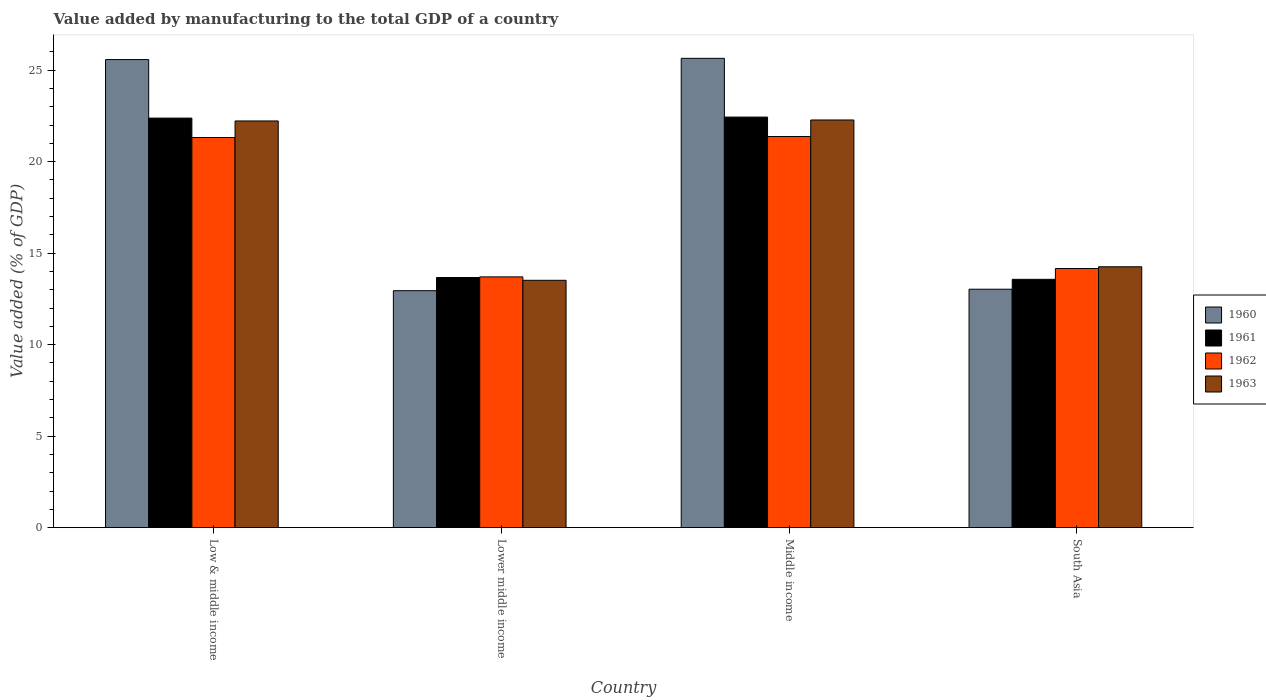How many different coloured bars are there?
Your answer should be very brief. 4. Are the number of bars per tick equal to the number of legend labels?
Give a very brief answer. Yes. Are the number of bars on each tick of the X-axis equal?
Offer a terse response. Yes. How many bars are there on the 4th tick from the left?
Keep it short and to the point. 4. How many bars are there on the 1st tick from the right?
Offer a terse response. 4. In how many cases, is the number of bars for a given country not equal to the number of legend labels?
Your answer should be very brief. 0. What is the value added by manufacturing to the total GDP in 1963 in South Asia?
Your answer should be compact. 14.26. Across all countries, what is the maximum value added by manufacturing to the total GDP in 1960?
Provide a short and direct response. 25.65. Across all countries, what is the minimum value added by manufacturing to the total GDP in 1962?
Ensure brevity in your answer.  13.7. In which country was the value added by manufacturing to the total GDP in 1963 maximum?
Give a very brief answer. Middle income. In which country was the value added by manufacturing to the total GDP in 1963 minimum?
Your answer should be very brief. Lower middle income. What is the total value added by manufacturing to the total GDP in 1963 in the graph?
Give a very brief answer. 72.27. What is the difference between the value added by manufacturing to the total GDP in 1961 in Low & middle income and that in Middle income?
Keep it short and to the point. -0.06. What is the difference between the value added by manufacturing to the total GDP in 1961 in South Asia and the value added by manufacturing to the total GDP in 1963 in Lower middle income?
Your answer should be very brief. 0.05. What is the average value added by manufacturing to the total GDP in 1963 per country?
Keep it short and to the point. 18.07. What is the difference between the value added by manufacturing to the total GDP of/in 1963 and value added by manufacturing to the total GDP of/in 1960 in South Asia?
Ensure brevity in your answer.  1.23. What is the ratio of the value added by manufacturing to the total GDP in 1963 in Low & middle income to that in Lower middle income?
Keep it short and to the point. 1.64. Is the value added by manufacturing to the total GDP in 1962 in Lower middle income less than that in South Asia?
Make the answer very short. Yes. Is the difference between the value added by manufacturing to the total GDP in 1963 in Low & middle income and Lower middle income greater than the difference between the value added by manufacturing to the total GDP in 1960 in Low & middle income and Lower middle income?
Give a very brief answer. No. What is the difference between the highest and the second highest value added by manufacturing to the total GDP in 1963?
Your response must be concise. -8.02. What is the difference between the highest and the lowest value added by manufacturing to the total GDP in 1960?
Your answer should be very brief. 12.7. In how many countries, is the value added by manufacturing to the total GDP in 1960 greater than the average value added by manufacturing to the total GDP in 1960 taken over all countries?
Provide a short and direct response. 2. Is the sum of the value added by manufacturing to the total GDP in 1960 in Middle income and South Asia greater than the maximum value added by manufacturing to the total GDP in 1961 across all countries?
Your response must be concise. Yes. Is it the case that in every country, the sum of the value added by manufacturing to the total GDP in 1960 and value added by manufacturing to the total GDP in 1963 is greater than the sum of value added by manufacturing to the total GDP in 1962 and value added by manufacturing to the total GDP in 1961?
Offer a terse response. No. What is the difference between two consecutive major ticks on the Y-axis?
Provide a short and direct response. 5. Are the values on the major ticks of Y-axis written in scientific E-notation?
Ensure brevity in your answer.  No. How are the legend labels stacked?
Give a very brief answer. Vertical. What is the title of the graph?
Your response must be concise. Value added by manufacturing to the total GDP of a country. What is the label or title of the X-axis?
Offer a very short reply. Country. What is the label or title of the Y-axis?
Keep it short and to the point. Value added (% of GDP). What is the Value added (% of GDP) in 1960 in Low & middle income?
Make the answer very short. 25.58. What is the Value added (% of GDP) of 1961 in Low & middle income?
Provide a succinct answer. 22.38. What is the Value added (% of GDP) of 1962 in Low & middle income?
Provide a short and direct response. 21.32. What is the Value added (% of GDP) of 1963 in Low & middle income?
Keep it short and to the point. 22.22. What is the Value added (% of GDP) in 1960 in Lower middle income?
Provide a short and direct response. 12.95. What is the Value added (% of GDP) of 1961 in Lower middle income?
Your answer should be compact. 13.67. What is the Value added (% of GDP) in 1962 in Lower middle income?
Your response must be concise. 13.7. What is the Value added (% of GDP) in 1963 in Lower middle income?
Your answer should be very brief. 13.52. What is the Value added (% of GDP) of 1960 in Middle income?
Make the answer very short. 25.65. What is the Value added (% of GDP) in 1961 in Middle income?
Your answer should be very brief. 22.44. What is the Value added (% of GDP) of 1962 in Middle income?
Provide a short and direct response. 21.37. What is the Value added (% of GDP) of 1963 in Middle income?
Make the answer very short. 22.28. What is the Value added (% of GDP) in 1960 in South Asia?
Ensure brevity in your answer.  13.03. What is the Value added (% of GDP) in 1961 in South Asia?
Make the answer very short. 13.57. What is the Value added (% of GDP) in 1962 in South Asia?
Give a very brief answer. 14.16. What is the Value added (% of GDP) in 1963 in South Asia?
Your answer should be compact. 14.26. Across all countries, what is the maximum Value added (% of GDP) in 1960?
Provide a short and direct response. 25.65. Across all countries, what is the maximum Value added (% of GDP) in 1961?
Offer a very short reply. 22.44. Across all countries, what is the maximum Value added (% of GDP) of 1962?
Your answer should be compact. 21.37. Across all countries, what is the maximum Value added (% of GDP) of 1963?
Provide a short and direct response. 22.28. Across all countries, what is the minimum Value added (% of GDP) in 1960?
Make the answer very short. 12.95. Across all countries, what is the minimum Value added (% of GDP) in 1961?
Your response must be concise. 13.57. Across all countries, what is the minimum Value added (% of GDP) in 1962?
Your answer should be very brief. 13.7. Across all countries, what is the minimum Value added (% of GDP) in 1963?
Your answer should be very brief. 13.52. What is the total Value added (% of GDP) in 1960 in the graph?
Make the answer very short. 77.2. What is the total Value added (% of GDP) in 1961 in the graph?
Your response must be concise. 72.05. What is the total Value added (% of GDP) in 1962 in the graph?
Offer a terse response. 70.56. What is the total Value added (% of GDP) of 1963 in the graph?
Your response must be concise. 72.27. What is the difference between the Value added (% of GDP) in 1960 in Low & middle income and that in Lower middle income?
Give a very brief answer. 12.63. What is the difference between the Value added (% of GDP) of 1961 in Low & middle income and that in Lower middle income?
Make the answer very short. 8.71. What is the difference between the Value added (% of GDP) of 1962 in Low & middle income and that in Lower middle income?
Offer a terse response. 7.62. What is the difference between the Value added (% of GDP) of 1963 in Low & middle income and that in Lower middle income?
Your answer should be very brief. 8.71. What is the difference between the Value added (% of GDP) in 1960 in Low & middle income and that in Middle income?
Give a very brief answer. -0.07. What is the difference between the Value added (% of GDP) in 1961 in Low & middle income and that in Middle income?
Provide a short and direct response. -0.06. What is the difference between the Value added (% of GDP) in 1962 in Low & middle income and that in Middle income?
Provide a short and direct response. -0.05. What is the difference between the Value added (% of GDP) in 1963 in Low & middle income and that in Middle income?
Offer a very short reply. -0.05. What is the difference between the Value added (% of GDP) of 1960 in Low & middle income and that in South Asia?
Your response must be concise. 12.55. What is the difference between the Value added (% of GDP) of 1961 in Low & middle income and that in South Asia?
Offer a terse response. 8.81. What is the difference between the Value added (% of GDP) of 1962 in Low & middle income and that in South Asia?
Keep it short and to the point. 7.16. What is the difference between the Value added (% of GDP) in 1963 in Low & middle income and that in South Asia?
Make the answer very short. 7.97. What is the difference between the Value added (% of GDP) in 1960 in Lower middle income and that in Middle income?
Provide a succinct answer. -12.7. What is the difference between the Value added (% of GDP) in 1961 in Lower middle income and that in Middle income?
Ensure brevity in your answer.  -8.77. What is the difference between the Value added (% of GDP) of 1962 in Lower middle income and that in Middle income?
Offer a terse response. -7.67. What is the difference between the Value added (% of GDP) of 1963 in Lower middle income and that in Middle income?
Your answer should be compact. -8.76. What is the difference between the Value added (% of GDP) in 1960 in Lower middle income and that in South Asia?
Ensure brevity in your answer.  -0.08. What is the difference between the Value added (% of GDP) of 1961 in Lower middle income and that in South Asia?
Ensure brevity in your answer.  0.1. What is the difference between the Value added (% of GDP) of 1962 in Lower middle income and that in South Asia?
Your response must be concise. -0.46. What is the difference between the Value added (% of GDP) of 1963 in Lower middle income and that in South Asia?
Provide a short and direct response. -0.74. What is the difference between the Value added (% of GDP) in 1960 in Middle income and that in South Asia?
Your answer should be very brief. 12.62. What is the difference between the Value added (% of GDP) of 1961 in Middle income and that in South Asia?
Give a very brief answer. 8.87. What is the difference between the Value added (% of GDP) of 1962 in Middle income and that in South Asia?
Your answer should be very brief. 7.21. What is the difference between the Value added (% of GDP) in 1963 in Middle income and that in South Asia?
Provide a succinct answer. 8.02. What is the difference between the Value added (% of GDP) of 1960 in Low & middle income and the Value added (% of GDP) of 1961 in Lower middle income?
Your answer should be very brief. 11.91. What is the difference between the Value added (% of GDP) in 1960 in Low & middle income and the Value added (% of GDP) in 1962 in Lower middle income?
Give a very brief answer. 11.88. What is the difference between the Value added (% of GDP) in 1960 in Low & middle income and the Value added (% of GDP) in 1963 in Lower middle income?
Your response must be concise. 12.06. What is the difference between the Value added (% of GDP) in 1961 in Low & middle income and the Value added (% of GDP) in 1962 in Lower middle income?
Ensure brevity in your answer.  8.68. What is the difference between the Value added (% of GDP) of 1961 in Low & middle income and the Value added (% of GDP) of 1963 in Lower middle income?
Your answer should be compact. 8.86. What is the difference between the Value added (% of GDP) in 1962 in Low & middle income and the Value added (% of GDP) in 1963 in Lower middle income?
Ensure brevity in your answer.  7.8. What is the difference between the Value added (% of GDP) of 1960 in Low & middle income and the Value added (% of GDP) of 1961 in Middle income?
Your answer should be compact. 3.14. What is the difference between the Value added (% of GDP) of 1960 in Low & middle income and the Value added (% of GDP) of 1962 in Middle income?
Your answer should be compact. 4.21. What is the difference between the Value added (% of GDP) of 1960 in Low & middle income and the Value added (% of GDP) of 1963 in Middle income?
Offer a terse response. 3.3. What is the difference between the Value added (% of GDP) in 1961 in Low & middle income and the Value added (% of GDP) in 1962 in Middle income?
Keep it short and to the point. 1.01. What is the difference between the Value added (% of GDP) in 1961 in Low & middle income and the Value added (% of GDP) in 1963 in Middle income?
Your answer should be very brief. 0.1. What is the difference between the Value added (% of GDP) in 1962 in Low & middle income and the Value added (% of GDP) in 1963 in Middle income?
Provide a succinct answer. -0.96. What is the difference between the Value added (% of GDP) of 1960 in Low & middle income and the Value added (% of GDP) of 1961 in South Asia?
Offer a very short reply. 12.01. What is the difference between the Value added (% of GDP) in 1960 in Low & middle income and the Value added (% of GDP) in 1962 in South Asia?
Make the answer very short. 11.42. What is the difference between the Value added (% of GDP) in 1960 in Low & middle income and the Value added (% of GDP) in 1963 in South Asia?
Offer a terse response. 11.32. What is the difference between the Value added (% of GDP) in 1961 in Low & middle income and the Value added (% of GDP) in 1962 in South Asia?
Offer a very short reply. 8.22. What is the difference between the Value added (% of GDP) of 1961 in Low & middle income and the Value added (% of GDP) of 1963 in South Asia?
Provide a succinct answer. 8.12. What is the difference between the Value added (% of GDP) in 1962 in Low & middle income and the Value added (% of GDP) in 1963 in South Asia?
Give a very brief answer. 7.06. What is the difference between the Value added (% of GDP) of 1960 in Lower middle income and the Value added (% of GDP) of 1961 in Middle income?
Ensure brevity in your answer.  -9.49. What is the difference between the Value added (% of GDP) of 1960 in Lower middle income and the Value added (% of GDP) of 1962 in Middle income?
Make the answer very short. -8.43. What is the difference between the Value added (% of GDP) in 1960 in Lower middle income and the Value added (% of GDP) in 1963 in Middle income?
Give a very brief answer. -9.33. What is the difference between the Value added (% of GDP) of 1961 in Lower middle income and the Value added (% of GDP) of 1962 in Middle income?
Ensure brevity in your answer.  -7.71. What is the difference between the Value added (% of GDP) of 1961 in Lower middle income and the Value added (% of GDP) of 1963 in Middle income?
Your answer should be compact. -8.61. What is the difference between the Value added (% of GDP) of 1962 in Lower middle income and the Value added (% of GDP) of 1963 in Middle income?
Your answer should be compact. -8.57. What is the difference between the Value added (% of GDP) in 1960 in Lower middle income and the Value added (% of GDP) in 1961 in South Asia?
Give a very brief answer. -0.62. What is the difference between the Value added (% of GDP) in 1960 in Lower middle income and the Value added (% of GDP) in 1962 in South Asia?
Make the answer very short. -1.21. What is the difference between the Value added (% of GDP) of 1960 in Lower middle income and the Value added (% of GDP) of 1963 in South Asia?
Offer a very short reply. -1.31. What is the difference between the Value added (% of GDP) of 1961 in Lower middle income and the Value added (% of GDP) of 1962 in South Asia?
Provide a succinct answer. -0.49. What is the difference between the Value added (% of GDP) of 1961 in Lower middle income and the Value added (% of GDP) of 1963 in South Asia?
Provide a short and direct response. -0.59. What is the difference between the Value added (% of GDP) in 1962 in Lower middle income and the Value added (% of GDP) in 1963 in South Asia?
Provide a short and direct response. -0.55. What is the difference between the Value added (% of GDP) in 1960 in Middle income and the Value added (% of GDP) in 1961 in South Asia?
Ensure brevity in your answer.  12.08. What is the difference between the Value added (% of GDP) of 1960 in Middle income and the Value added (% of GDP) of 1962 in South Asia?
Your answer should be very brief. 11.49. What is the difference between the Value added (% of GDP) in 1960 in Middle income and the Value added (% of GDP) in 1963 in South Asia?
Your answer should be very brief. 11.39. What is the difference between the Value added (% of GDP) of 1961 in Middle income and the Value added (% of GDP) of 1962 in South Asia?
Your answer should be compact. 8.28. What is the difference between the Value added (% of GDP) in 1961 in Middle income and the Value added (% of GDP) in 1963 in South Asia?
Your answer should be compact. 8.18. What is the difference between the Value added (% of GDP) of 1962 in Middle income and the Value added (% of GDP) of 1963 in South Asia?
Your answer should be compact. 7.12. What is the average Value added (% of GDP) in 1960 per country?
Offer a very short reply. 19.3. What is the average Value added (% of GDP) of 1961 per country?
Your answer should be very brief. 18.01. What is the average Value added (% of GDP) of 1962 per country?
Give a very brief answer. 17.64. What is the average Value added (% of GDP) of 1963 per country?
Your answer should be compact. 18.07. What is the difference between the Value added (% of GDP) in 1960 and Value added (% of GDP) in 1961 in Low & middle income?
Your response must be concise. 3.2. What is the difference between the Value added (% of GDP) of 1960 and Value added (% of GDP) of 1962 in Low & middle income?
Offer a very short reply. 4.26. What is the difference between the Value added (% of GDP) in 1960 and Value added (% of GDP) in 1963 in Low & middle income?
Give a very brief answer. 3.35. What is the difference between the Value added (% of GDP) of 1961 and Value added (% of GDP) of 1962 in Low & middle income?
Your response must be concise. 1.06. What is the difference between the Value added (% of GDP) in 1961 and Value added (% of GDP) in 1963 in Low & middle income?
Offer a very short reply. 0.16. What is the difference between the Value added (% of GDP) of 1962 and Value added (% of GDP) of 1963 in Low & middle income?
Ensure brevity in your answer.  -0.9. What is the difference between the Value added (% of GDP) of 1960 and Value added (% of GDP) of 1961 in Lower middle income?
Provide a succinct answer. -0.72. What is the difference between the Value added (% of GDP) of 1960 and Value added (% of GDP) of 1962 in Lower middle income?
Your answer should be very brief. -0.75. What is the difference between the Value added (% of GDP) of 1960 and Value added (% of GDP) of 1963 in Lower middle income?
Make the answer very short. -0.57. What is the difference between the Value added (% of GDP) of 1961 and Value added (% of GDP) of 1962 in Lower middle income?
Offer a very short reply. -0.04. What is the difference between the Value added (% of GDP) of 1961 and Value added (% of GDP) of 1963 in Lower middle income?
Offer a terse response. 0.15. What is the difference between the Value added (% of GDP) of 1962 and Value added (% of GDP) of 1963 in Lower middle income?
Make the answer very short. 0.19. What is the difference between the Value added (% of GDP) in 1960 and Value added (% of GDP) in 1961 in Middle income?
Ensure brevity in your answer.  3.21. What is the difference between the Value added (% of GDP) in 1960 and Value added (% of GDP) in 1962 in Middle income?
Make the answer very short. 4.27. What is the difference between the Value added (% of GDP) in 1960 and Value added (% of GDP) in 1963 in Middle income?
Offer a terse response. 3.37. What is the difference between the Value added (% of GDP) in 1961 and Value added (% of GDP) in 1962 in Middle income?
Your answer should be compact. 1.06. What is the difference between the Value added (% of GDP) of 1961 and Value added (% of GDP) of 1963 in Middle income?
Your answer should be very brief. 0.16. What is the difference between the Value added (% of GDP) in 1962 and Value added (% of GDP) in 1963 in Middle income?
Ensure brevity in your answer.  -0.9. What is the difference between the Value added (% of GDP) in 1960 and Value added (% of GDP) in 1961 in South Asia?
Make the answer very short. -0.54. What is the difference between the Value added (% of GDP) of 1960 and Value added (% of GDP) of 1962 in South Asia?
Offer a very short reply. -1.13. What is the difference between the Value added (% of GDP) in 1960 and Value added (% of GDP) in 1963 in South Asia?
Offer a very short reply. -1.23. What is the difference between the Value added (% of GDP) in 1961 and Value added (% of GDP) in 1962 in South Asia?
Your answer should be very brief. -0.59. What is the difference between the Value added (% of GDP) of 1961 and Value added (% of GDP) of 1963 in South Asia?
Keep it short and to the point. -0.69. What is the difference between the Value added (% of GDP) of 1962 and Value added (% of GDP) of 1963 in South Asia?
Ensure brevity in your answer.  -0.1. What is the ratio of the Value added (% of GDP) of 1960 in Low & middle income to that in Lower middle income?
Ensure brevity in your answer.  1.98. What is the ratio of the Value added (% of GDP) in 1961 in Low & middle income to that in Lower middle income?
Provide a succinct answer. 1.64. What is the ratio of the Value added (% of GDP) in 1962 in Low & middle income to that in Lower middle income?
Offer a terse response. 1.56. What is the ratio of the Value added (% of GDP) of 1963 in Low & middle income to that in Lower middle income?
Offer a terse response. 1.64. What is the ratio of the Value added (% of GDP) in 1960 in Low & middle income to that in Middle income?
Provide a succinct answer. 1. What is the ratio of the Value added (% of GDP) of 1960 in Low & middle income to that in South Asia?
Offer a very short reply. 1.96. What is the ratio of the Value added (% of GDP) in 1961 in Low & middle income to that in South Asia?
Offer a very short reply. 1.65. What is the ratio of the Value added (% of GDP) of 1962 in Low & middle income to that in South Asia?
Provide a succinct answer. 1.51. What is the ratio of the Value added (% of GDP) of 1963 in Low & middle income to that in South Asia?
Offer a very short reply. 1.56. What is the ratio of the Value added (% of GDP) of 1960 in Lower middle income to that in Middle income?
Ensure brevity in your answer.  0.5. What is the ratio of the Value added (% of GDP) in 1961 in Lower middle income to that in Middle income?
Keep it short and to the point. 0.61. What is the ratio of the Value added (% of GDP) of 1962 in Lower middle income to that in Middle income?
Your response must be concise. 0.64. What is the ratio of the Value added (% of GDP) of 1963 in Lower middle income to that in Middle income?
Offer a terse response. 0.61. What is the ratio of the Value added (% of GDP) in 1960 in Lower middle income to that in South Asia?
Give a very brief answer. 0.99. What is the ratio of the Value added (% of GDP) of 1961 in Lower middle income to that in South Asia?
Your answer should be very brief. 1.01. What is the ratio of the Value added (% of GDP) in 1963 in Lower middle income to that in South Asia?
Give a very brief answer. 0.95. What is the ratio of the Value added (% of GDP) of 1960 in Middle income to that in South Asia?
Give a very brief answer. 1.97. What is the ratio of the Value added (% of GDP) of 1961 in Middle income to that in South Asia?
Provide a short and direct response. 1.65. What is the ratio of the Value added (% of GDP) in 1962 in Middle income to that in South Asia?
Offer a terse response. 1.51. What is the ratio of the Value added (% of GDP) in 1963 in Middle income to that in South Asia?
Provide a succinct answer. 1.56. What is the difference between the highest and the second highest Value added (% of GDP) of 1960?
Ensure brevity in your answer.  0.07. What is the difference between the highest and the second highest Value added (% of GDP) of 1961?
Give a very brief answer. 0.06. What is the difference between the highest and the second highest Value added (% of GDP) in 1962?
Offer a very short reply. 0.05. What is the difference between the highest and the second highest Value added (% of GDP) in 1963?
Make the answer very short. 0.05. What is the difference between the highest and the lowest Value added (% of GDP) in 1960?
Make the answer very short. 12.7. What is the difference between the highest and the lowest Value added (% of GDP) in 1961?
Make the answer very short. 8.87. What is the difference between the highest and the lowest Value added (% of GDP) in 1962?
Make the answer very short. 7.67. What is the difference between the highest and the lowest Value added (% of GDP) in 1963?
Offer a very short reply. 8.76. 